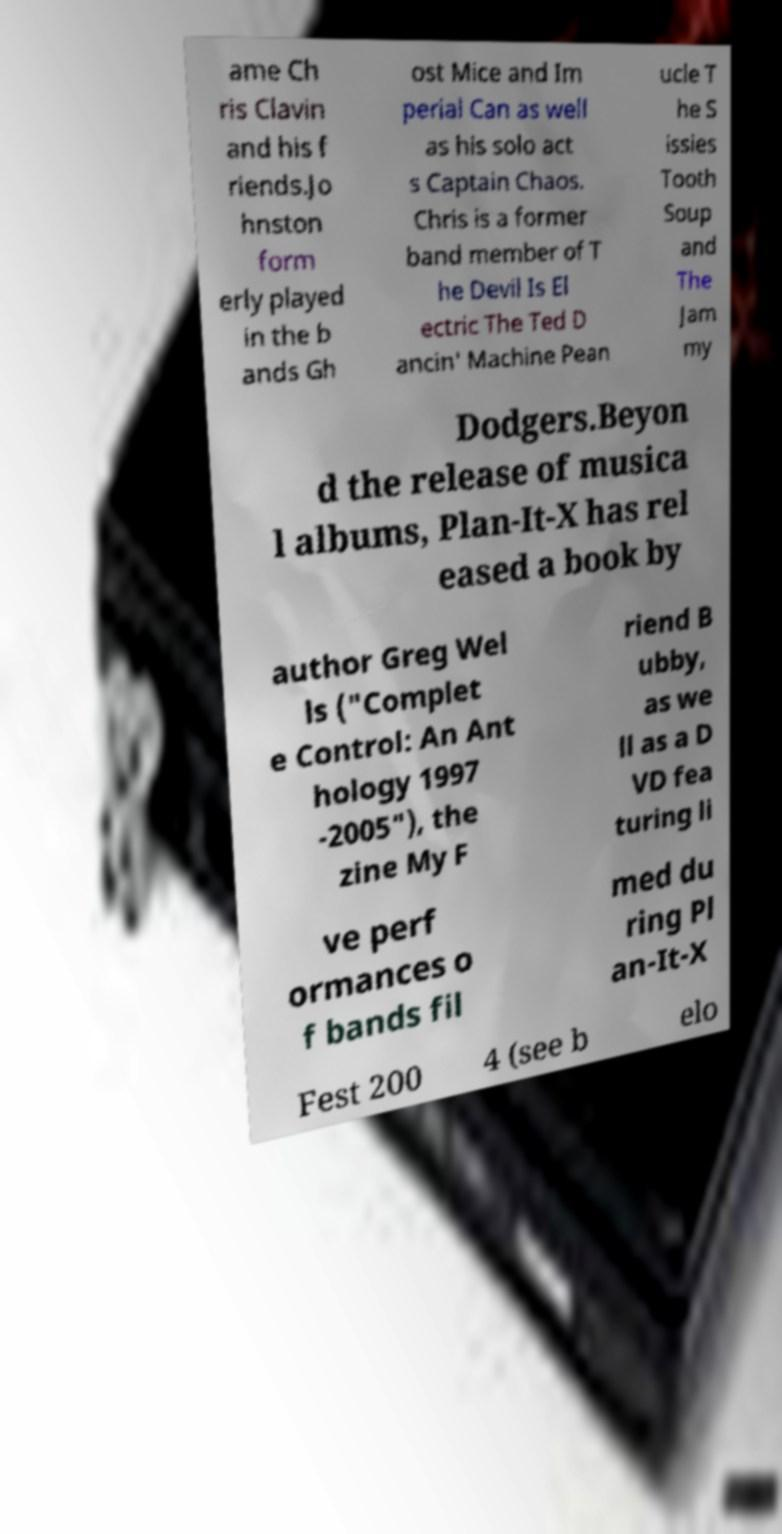Please read and relay the text visible in this image. What does it say? ame Ch ris Clavin and his f riends.Jo hnston form erly played in the b ands Gh ost Mice and Im perial Can as well as his solo act s Captain Chaos. Chris is a former band member of T he Devil Is El ectric The Ted D ancin' Machine Pean ucle T he S issies Tooth Soup and The Jam my Dodgers.Beyon d the release of musica l albums, Plan-It-X has rel eased a book by author Greg Wel ls ("Complet e Control: An Ant hology 1997 -2005"), the zine My F riend B ubby, as we ll as a D VD fea turing li ve perf ormances o f bands fil med du ring Pl an-It-X Fest 200 4 (see b elo 